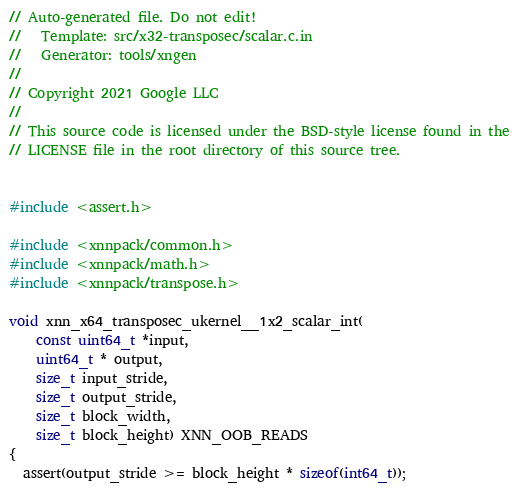Convert code to text. <code><loc_0><loc_0><loc_500><loc_500><_C_>// Auto-generated file. Do not edit!
//   Template: src/x32-transposec/scalar.c.in
//   Generator: tools/xngen
//
// Copyright 2021 Google LLC
//
// This source code is licensed under the BSD-style license found in the
// LICENSE file in the root directory of this source tree.


#include <assert.h>

#include <xnnpack/common.h>
#include <xnnpack/math.h>
#include <xnnpack/transpose.h>

void xnn_x64_transposec_ukernel__1x2_scalar_int(
    const uint64_t *input,
    uint64_t * output,
    size_t input_stride,
    size_t output_stride,
    size_t block_width,
    size_t block_height) XNN_OOB_READS
{
  assert(output_stride >= block_height * sizeof(int64_t));</code> 